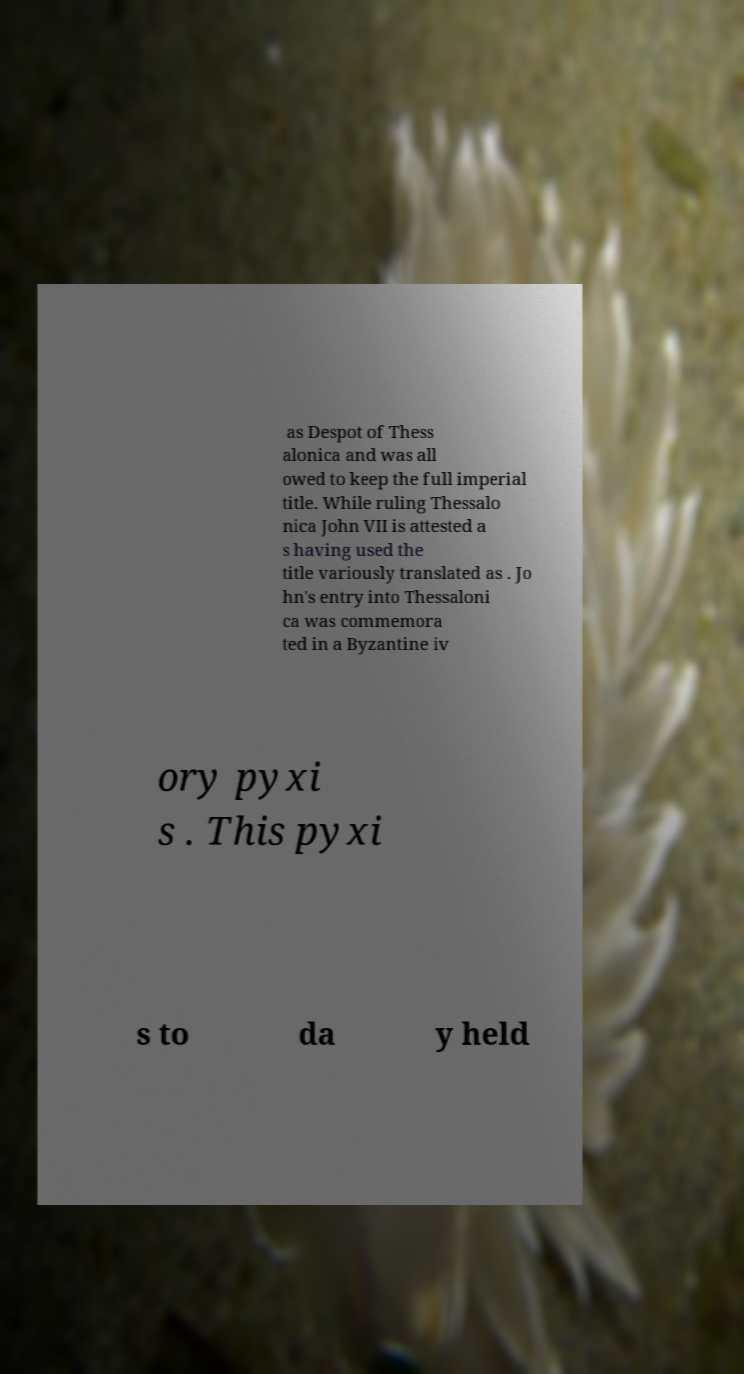I need the written content from this picture converted into text. Can you do that? as Despot of Thess alonica and was all owed to keep the full imperial title. While ruling Thessalo nica John VII is attested a s having used the title variously translated as . Jo hn's entry into Thessaloni ca was commemora ted in a Byzantine iv ory pyxi s . This pyxi s to da y held 